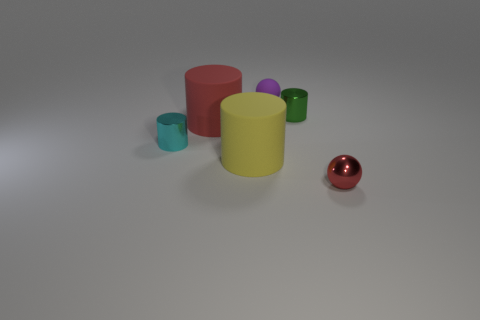What is the color of the other small cylinder that is the same material as the small cyan cylinder?
Ensure brevity in your answer.  Green. There is a metallic ball; does it have the same color as the matte cylinder on the left side of the yellow thing?
Give a very brief answer. Yes. Are there any small metal things that are in front of the small shiny cylinder to the left of the small shiny cylinder on the right side of the big red object?
Offer a very short reply. Yes. There is a green object that is the same material as the cyan object; what shape is it?
Offer a terse response. Cylinder. What is the shape of the cyan object?
Make the answer very short. Cylinder. Is the shape of the rubber thing to the right of the large yellow matte cylinder the same as  the red metal thing?
Provide a short and direct response. Yes. Are there more tiny balls left of the small metal ball than cyan shiny things that are right of the purple ball?
Your response must be concise. Yes. How many other things are the same size as the green metallic thing?
Give a very brief answer. 3. Does the red shiny object have the same shape as the red object left of the red shiny thing?
Keep it short and to the point. No. How many metallic things are either tiny red balls or tiny green objects?
Keep it short and to the point. 2. 